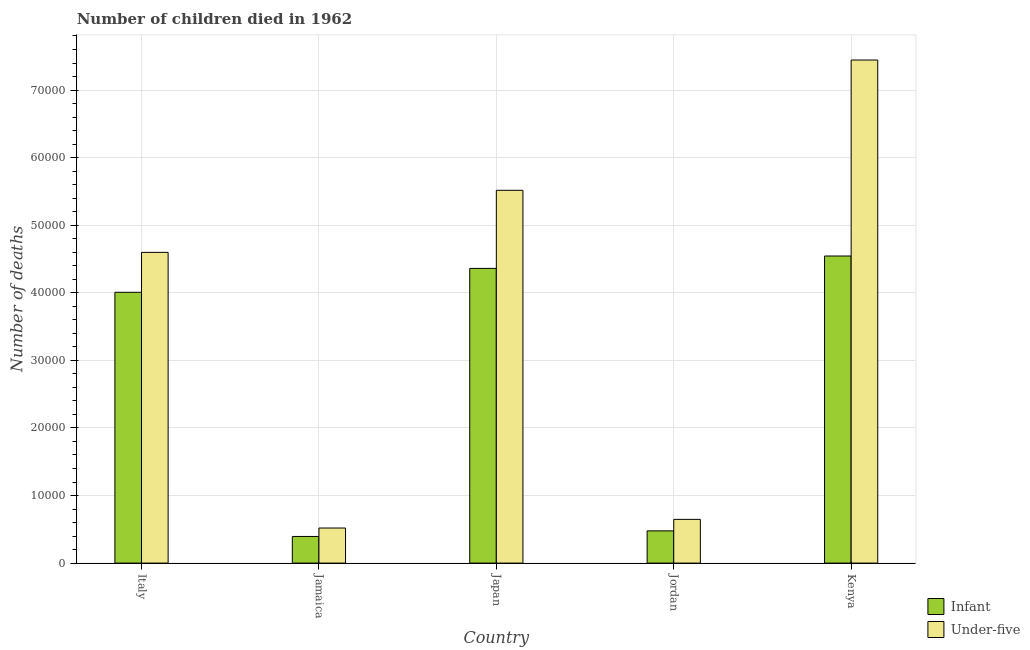Are the number of bars on each tick of the X-axis equal?
Provide a short and direct response. Yes. How many bars are there on the 1st tick from the left?
Your answer should be compact. 2. What is the label of the 5th group of bars from the left?
Your response must be concise. Kenya. What is the number of infant deaths in Japan?
Keep it short and to the point. 4.36e+04. Across all countries, what is the maximum number of under-five deaths?
Your answer should be compact. 7.44e+04. Across all countries, what is the minimum number of under-five deaths?
Provide a succinct answer. 5189. In which country was the number of infant deaths maximum?
Offer a terse response. Kenya. In which country was the number of under-five deaths minimum?
Your response must be concise. Jamaica. What is the total number of under-five deaths in the graph?
Provide a short and direct response. 1.87e+05. What is the difference between the number of under-five deaths in Italy and that in Kenya?
Provide a short and direct response. -2.85e+04. What is the difference between the number of infant deaths in Japan and the number of under-five deaths in Jamaica?
Offer a very short reply. 3.84e+04. What is the average number of under-five deaths per country?
Offer a very short reply. 3.74e+04. What is the difference between the number of under-five deaths and number of infant deaths in Kenya?
Offer a very short reply. 2.90e+04. What is the ratio of the number of infant deaths in Italy to that in Jamaica?
Ensure brevity in your answer.  10.17. Is the number of under-five deaths in Japan less than that in Kenya?
Offer a very short reply. Yes. Is the difference between the number of infant deaths in Italy and Kenya greater than the difference between the number of under-five deaths in Italy and Kenya?
Your answer should be compact. Yes. What is the difference between the highest and the second highest number of under-five deaths?
Provide a short and direct response. 1.93e+04. What is the difference between the highest and the lowest number of infant deaths?
Provide a short and direct response. 4.15e+04. In how many countries, is the number of under-five deaths greater than the average number of under-five deaths taken over all countries?
Keep it short and to the point. 3. Is the sum of the number of under-five deaths in Jamaica and Kenya greater than the maximum number of infant deaths across all countries?
Your response must be concise. Yes. What does the 2nd bar from the left in Jamaica represents?
Your response must be concise. Under-five. What does the 2nd bar from the right in Jamaica represents?
Your answer should be compact. Infant. How many bars are there?
Ensure brevity in your answer.  10. Are all the bars in the graph horizontal?
Ensure brevity in your answer.  No. What is the difference between two consecutive major ticks on the Y-axis?
Provide a short and direct response. 10000. Are the values on the major ticks of Y-axis written in scientific E-notation?
Provide a short and direct response. No. Does the graph contain any zero values?
Keep it short and to the point. No. Where does the legend appear in the graph?
Your answer should be very brief. Bottom right. What is the title of the graph?
Ensure brevity in your answer.  Number of children died in 1962. What is the label or title of the X-axis?
Keep it short and to the point. Country. What is the label or title of the Y-axis?
Make the answer very short. Number of deaths. What is the Number of deaths in Infant in Italy?
Ensure brevity in your answer.  4.01e+04. What is the Number of deaths in Under-five in Italy?
Make the answer very short. 4.60e+04. What is the Number of deaths in Infant in Jamaica?
Provide a short and direct response. 3941. What is the Number of deaths of Under-five in Jamaica?
Offer a very short reply. 5189. What is the Number of deaths of Infant in Japan?
Make the answer very short. 4.36e+04. What is the Number of deaths in Under-five in Japan?
Your answer should be compact. 5.52e+04. What is the Number of deaths in Infant in Jordan?
Offer a very short reply. 4769. What is the Number of deaths of Under-five in Jordan?
Your answer should be very brief. 6471. What is the Number of deaths in Infant in Kenya?
Keep it short and to the point. 4.54e+04. What is the Number of deaths of Under-five in Kenya?
Provide a short and direct response. 7.44e+04. Across all countries, what is the maximum Number of deaths of Infant?
Keep it short and to the point. 4.54e+04. Across all countries, what is the maximum Number of deaths in Under-five?
Provide a short and direct response. 7.44e+04. Across all countries, what is the minimum Number of deaths in Infant?
Keep it short and to the point. 3941. Across all countries, what is the minimum Number of deaths in Under-five?
Your answer should be very brief. 5189. What is the total Number of deaths of Infant in the graph?
Make the answer very short. 1.38e+05. What is the total Number of deaths of Under-five in the graph?
Your answer should be very brief. 1.87e+05. What is the difference between the Number of deaths in Infant in Italy and that in Jamaica?
Provide a succinct answer. 3.61e+04. What is the difference between the Number of deaths in Under-five in Italy and that in Jamaica?
Provide a short and direct response. 4.08e+04. What is the difference between the Number of deaths of Infant in Italy and that in Japan?
Provide a short and direct response. -3535. What is the difference between the Number of deaths of Under-five in Italy and that in Japan?
Ensure brevity in your answer.  -9184. What is the difference between the Number of deaths in Infant in Italy and that in Jordan?
Your answer should be very brief. 3.53e+04. What is the difference between the Number of deaths in Under-five in Italy and that in Jordan?
Offer a very short reply. 3.95e+04. What is the difference between the Number of deaths in Infant in Italy and that in Kenya?
Your answer should be very brief. -5369. What is the difference between the Number of deaths in Under-five in Italy and that in Kenya?
Offer a terse response. -2.85e+04. What is the difference between the Number of deaths of Infant in Jamaica and that in Japan?
Your response must be concise. -3.97e+04. What is the difference between the Number of deaths in Under-five in Jamaica and that in Japan?
Provide a succinct answer. -5.00e+04. What is the difference between the Number of deaths of Infant in Jamaica and that in Jordan?
Keep it short and to the point. -828. What is the difference between the Number of deaths of Under-five in Jamaica and that in Jordan?
Give a very brief answer. -1282. What is the difference between the Number of deaths of Infant in Jamaica and that in Kenya?
Offer a terse response. -4.15e+04. What is the difference between the Number of deaths of Under-five in Jamaica and that in Kenya?
Provide a succinct answer. -6.93e+04. What is the difference between the Number of deaths in Infant in Japan and that in Jordan?
Offer a terse response. 3.88e+04. What is the difference between the Number of deaths of Under-five in Japan and that in Jordan?
Your response must be concise. 4.87e+04. What is the difference between the Number of deaths of Infant in Japan and that in Kenya?
Your answer should be compact. -1834. What is the difference between the Number of deaths of Under-five in Japan and that in Kenya?
Offer a terse response. -1.93e+04. What is the difference between the Number of deaths of Infant in Jordan and that in Kenya?
Your answer should be compact. -4.07e+04. What is the difference between the Number of deaths of Under-five in Jordan and that in Kenya?
Your answer should be compact. -6.80e+04. What is the difference between the Number of deaths in Infant in Italy and the Number of deaths in Under-five in Jamaica?
Offer a terse response. 3.49e+04. What is the difference between the Number of deaths in Infant in Italy and the Number of deaths in Under-five in Japan?
Provide a succinct answer. -1.51e+04. What is the difference between the Number of deaths of Infant in Italy and the Number of deaths of Under-five in Jordan?
Keep it short and to the point. 3.36e+04. What is the difference between the Number of deaths in Infant in Italy and the Number of deaths in Under-five in Kenya?
Offer a terse response. -3.44e+04. What is the difference between the Number of deaths in Infant in Jamaica and the Number of deaths in Under-five in Japan?
Provide a short and direct response. -5.12e+04. What is the difference between the Number of deaths in Infant in Jamaica and the Number of deaths in Under-five in Jordan?
Your response must be concise. -2530. What is the difference between the Number of deaths of Infant in Jamaica and the Number of deaths of Under-five in Kenya?
Ensure brevity in your answer.  -7.05e+04. What is the difference between the Number of deaths of Infant in Japan and the Number of deaths of Under-five in Jordan?
Offer a terse response. 3.71e+04. What is the difference between the Number of deaths of Infant in Japan and the Number of deaths of Under-five in Kenya?
Provide a short and direct response. -3.08e+04. What is the difference between the Number of deaths in Infant in Jordan and the Number of deaths in Under-five in Kenya?
Keep it short and to the point. -6.97e+04. What is the average Number of deaths of Infant per country?
Offer a terse response. 2.76e+04. What is the average Number of deaths of Under-five per country?
Your answer should be very brief. 3.74e+04. What is the difference between the Number of deaths in Infant and Number of deaths in Under-five in Italy?
Give a very brief answer. -5908. What is the difference between the Number of deaths in Infant and Number of deaths in Under-five in Jamaica?
Your answer should be very brief. -1248. What is the difference between the Number of deaths of Infant and Number of deaths of Under-five in Japan?
Offer a terse response. -1.16e+04. What is the difference between the Number of deaths of Infant and Number of deaths of Under-five in Jordan?
Give a very brief answer. -1702. What is the difference between the Number of deaths in Infant and Number of deaths in Under-five in Kenya?
Your response must be concise. -2.90e+04. What is the ratio of the Number of deaths of Infant in Italy to that in Jamaica?
Provide a succinct answer. 10.17. What is the ratio of the Number of deaths of Under-five in Italy to that in Jamaica?
Keep it short and to the point. 8.86. What is the ratio of the Number of deaths in Infant in Italy to that in Japan?
Ensure brevity in your answer.  0.92. What is the ratio of the Number of deaths in Under-five in Italy to that in Japan?
Offer a terse response. 0.83. What is the ratio of the Number of deaths of Infant in Italy to that in Jordan?
Your response must be concise. 8.4. What is the ratio of the Number of deaths in Under-five in Italy to that in Jordan?
Keep it short and to the point. 7.11. What is the ratio of the Number of deaths in Infant in Italy to that in Kenya?
Keep it short and to the point. 0.88. What is the ratio of the Number of deaths of Under-five in Italy to that in Kenya?
Your response must be concise. 0.62. What is the ratio of the Number of deaths in Infant in Jamaica to that in Japan?
Keep it short and to the point. 0.09. What is the ratio of the Number of deaths in Under-five in Jamaica to that in Japan?
Provide a short and direct response. 0.09. What is the ratio of the Number of deaths in Infant in Jamaica to that in Jordan?
Your answer should be compact. 0.83. What is the ratio of the Number of deaths of Under-five in Jamaica to that in Jordan?
Provide a succinct answer. 0.8. What is the ratio of the Number of deaths in Infant in Jamaica to that in Kenya?
Your answer should be very brief. 0.09. What is the ratio of the Number of deaths in Under-five in Jamaica to that in Kenya?
Ensure brevity in your answer.  0.07. What is the ratio of the Number of deaths in Infant in Japan to that in Jordan?
Offer a very short reply. 9.14. What is the ratio of the Number of deaths in Under-five in Japan to that in Jordan?
Offer a terse response. 8.52. What is the ratio of the Number of deaths of Infant in Japan to that in Kenya?
Offer a very short reply. 0.96. What is the ratio of the Number of deaths of Under-five in Japan to that in Kenya?
Provide a short and direct response. 0.74. What is the ratio of the Number of deaths in Infant in Jordan to that in Kenya?
Ensure brevity in your answer.  0.1. What is the ratio of the Number of deaths in Under-five in Jordan to that in Kenya?
Ensure brevity in your answer.  0.09. What is the difference between the highest and the second highest Number of deaths in Infant?
Your answer should be compact. 1834. What is the difference between the highest and the second highest Number of deaths in Under-five?
Your answer should be very brief. 1.93e+04. What is the difference between the highest and the lowest Number of deaths of Infant?
Make the answer very short. 4.15e+04. What is the difference between the highest and the lowest Number of deaths in Under-five?
Give a very brief answer. 6.93e+04. 